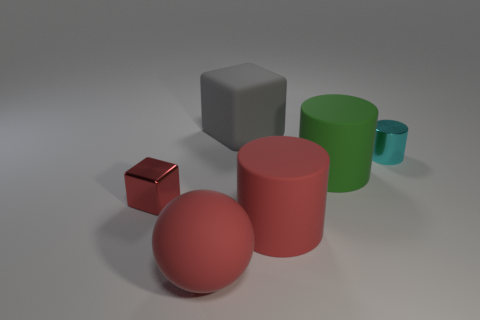Looking at the lighting, where is the light source located? The lighting in the image suggests that the light source is positioned above the objects, slightly off to the right. This is indicated by the shadows cast directly opposite to this direction, and the highlights visible on the upper surfaces of the objects. 